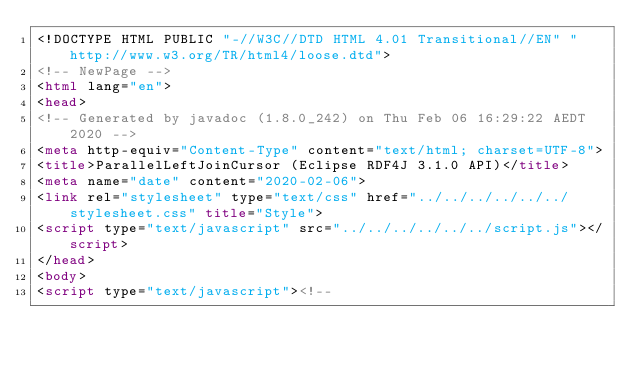Convert code to text. <code><loc_0><loc_0><loc_500><loc_500><_HTML_><!DOCTYPE HTML PUBLIC "-//W3C//DTD HTML 4.01 Transitional//EN" "http://www.w3.org/TR/html4/loose.dtd">
<!-- NewPage -->
<html lang="en">
<head>
<!-- Generated by javadoc (1.8.0_242) on Thu Feb 06 16:29:22 AEDT 2020 -->
<meta http-equiv="Content-Type" content="text/html; charset=UTF-8">
<title>ParallelLeftJoinCursor (Eclipse RDF4J 3.1.0 API)</title>
<meta name="date" content="2020-02-06">
<link rel="stylesheet" type="text/css" href="../../../../../../stylesheet.css" title="Style">
<script type="text/javascript" src="../../../../../../script.js"></script>
</head>
<body>
<script type="text/javascript"><!--</code> 